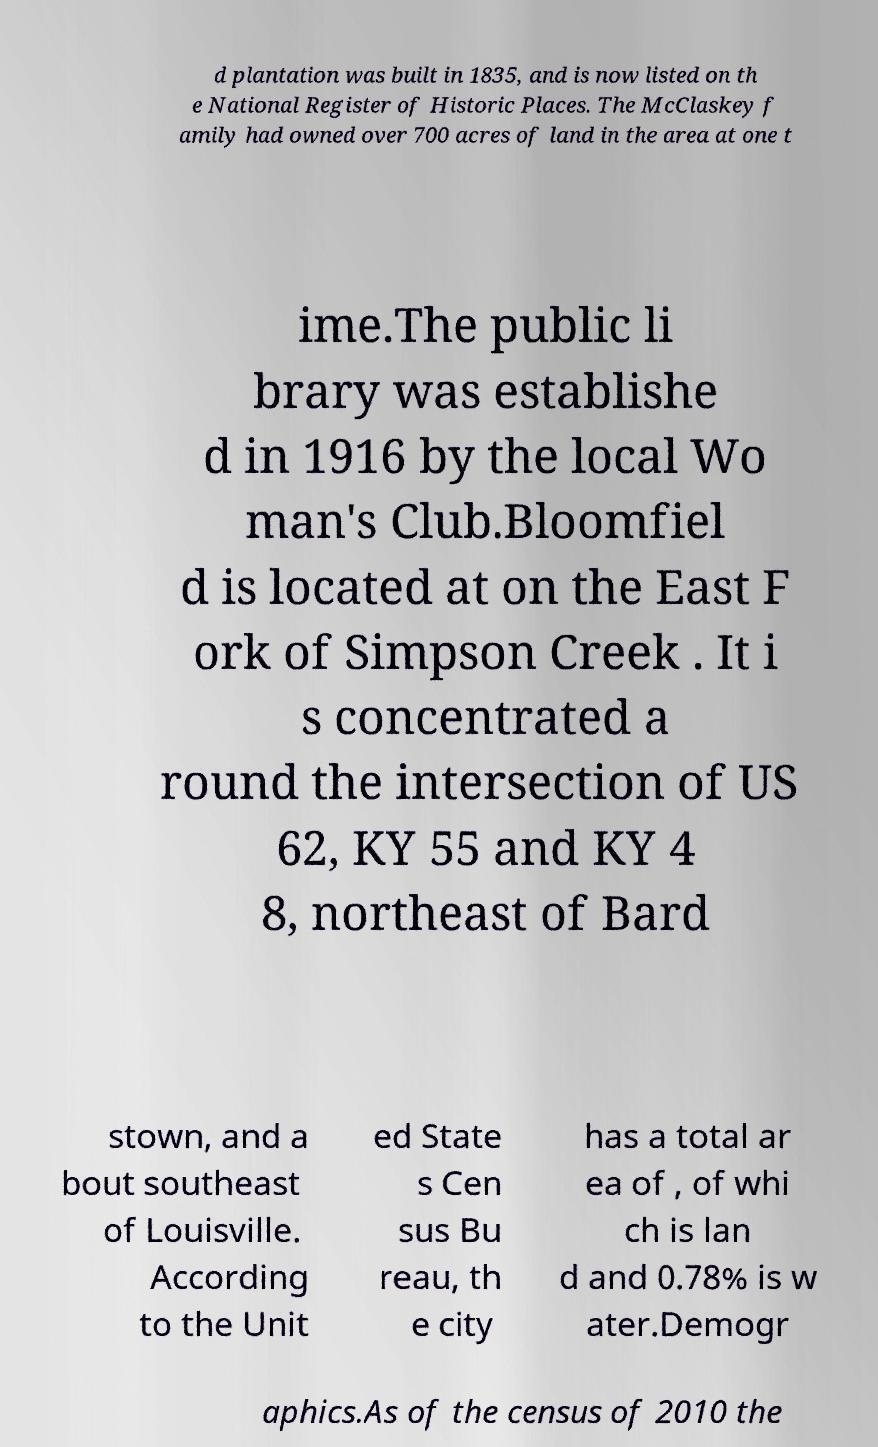I need the written content from this picture converted into text. Can you do that? d plantation was built in 1835, and is now listed on th e National Register of Historic Places. The McClaskey f amily had owned over 700 acres of land in the area at one t ime.The public li brary was establishe d in 1916 by the local Wo man's Club.Bloomfiel d is located at on the East F ork of Simpson Creek . It i s concentrated a round the intersection of US 62, KY 55 and KY 4 8, northeast of Bard stown, and a bout southeast of Louisville. According to the Unit ed State s Cen sus Bu reau, th e city has a total ar ea of , of whi ch is lan d and 0.78% is w ater.Demogr aphics.As of the census of 2010 the 